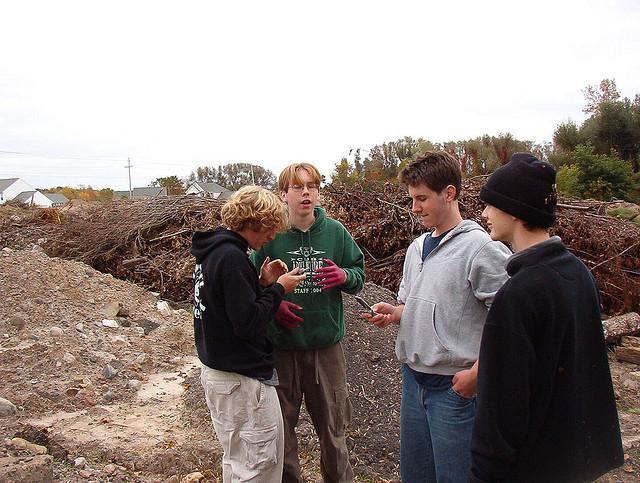How many boys?
Give a very brief answer. 4. How many boys are wearing a top with a hood?
Give a very brief answer. 3. How many people are in the picture?
Give a very brief answer. 4. 